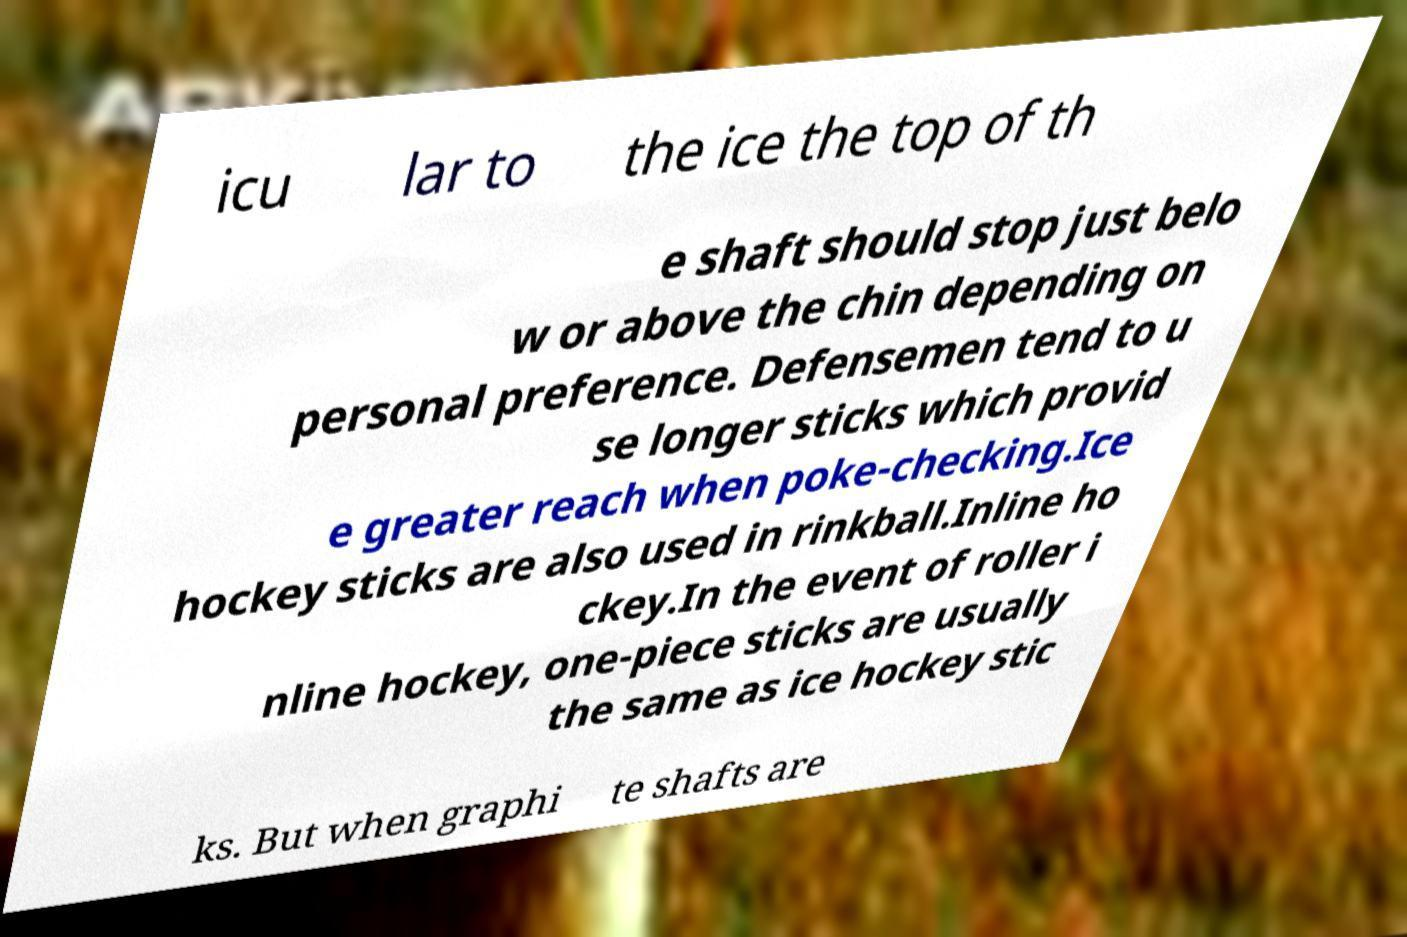Could you extract and type out the text from this image? icu lar to the ice the top of th e shaft should stop just belo w or above the chin depending on personal preference. Defensemen tend to u se longer sticks which provid e greater reach when poke-checking.Ice hockey sticks are also used in rinkball.Inline ho ckey.In the event of roller i nline hockey, one-piece sticks are usually the same as ice hockey stic ks. But when graphi te shafts are 